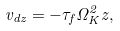<formula> <loc_0><loc_0><loc_500><loc_500>v _ { d z } = - \tau _ { f } \Omega _ { K } ^ { 2 } z ,</formula> 